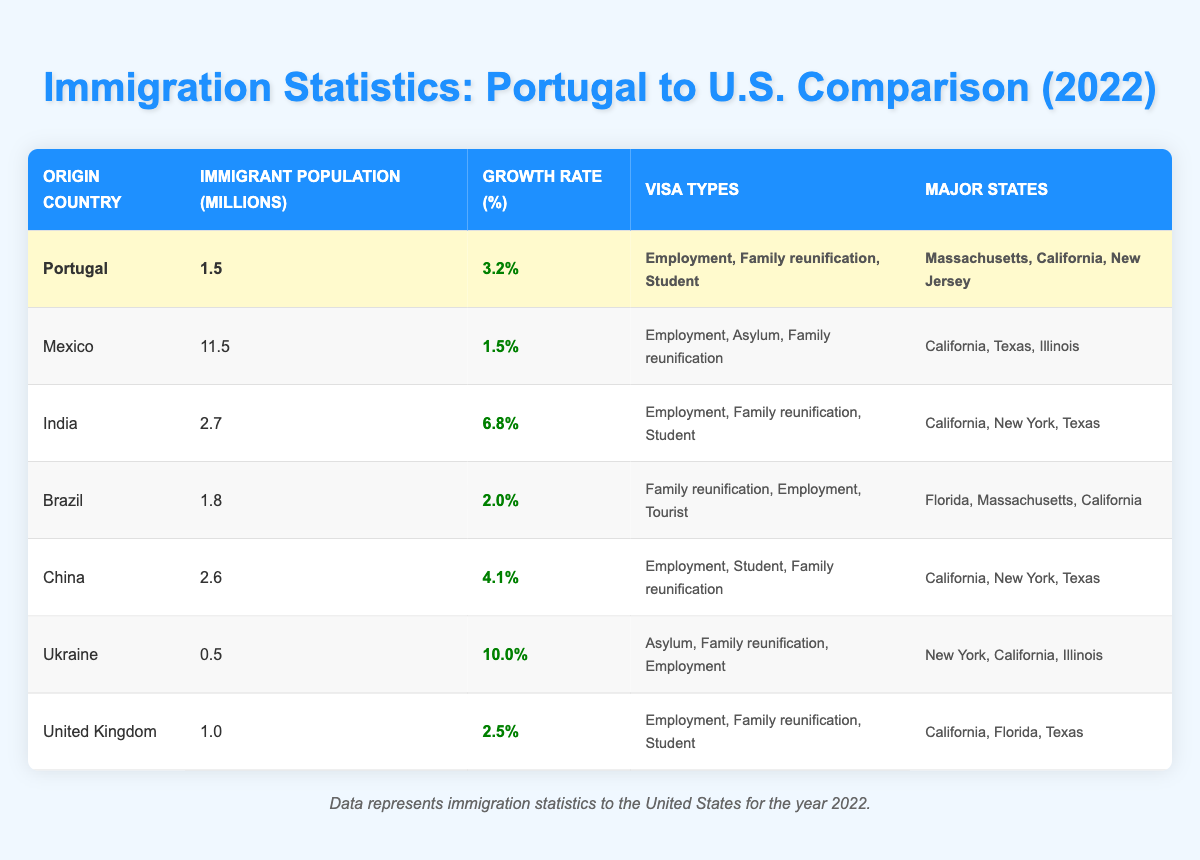What is the immigrant population from Portugal to the United States in 2022? The table shows that the immigrant population from Portugal to the United States in 2022 is 1.5 million.
Answer: 1.5 million Which country had the highest immigrant population in the United States in 2022? By comparing the immigrant populations listed in the table, Mexico has the highest population at 11.5 million.
Answer: Mexico What is the growth rate of Indian immigrants to the United States? The table indicates that the growth rate of Indian immigrants to the United States is 6.8%.
Answer: 6.8% How many countries listed have a growth rate higher than Portugal's 3.2%? In the table, the countries with a growth rate higher than 3.2% are India (6.8%), China (4.1%), and Ukraine (10.0%). This makes a total of 3 countries.
Answer: 3 countries Is the major state for Portuguese immigrants to the United States also a major state for Brazilian immigrants? By reviewing the table, Massachusetts is a major state for both Portuguese and Brazilian immigrants. Therefore, the answer is yes.
Answer: Yes What percentage of growth did Ukrainian immigrants experience in 2022? According to the table, Ukrainian immigrants experienced a growth rate of 10.0% in 2022.
Answer: 10.0% What is the average growth rate of all countries listed? To calculate the average growth rate, we add the growth rates (3.2 + 1.5 + 6.8 + 2.0 + 4.1 + 10.0 + 2.5 = 30.1) and divide by the number of countries (7). The average growth rate is 30.1 / 7 ≈ 4.3%.
Answer: 4.3% Which countries have 'Family reunification' as a visa type? The table shows that the countries with 'Family reunification' as a visa type are Portugal, Mexico, India, Brazil, China, Ukraine, and the United Kingdom. This totals to 7 countries.
Answer: 7 countries What is the difference in immigrant population between the United States entrants from Mexico and Portugal? From the table, the immigrant population from Mexico is 11.5 million, while from Portugal it is 1.5 million. The difference is 11.5 - 1.5 = 10 million.
Answer: 10 million 